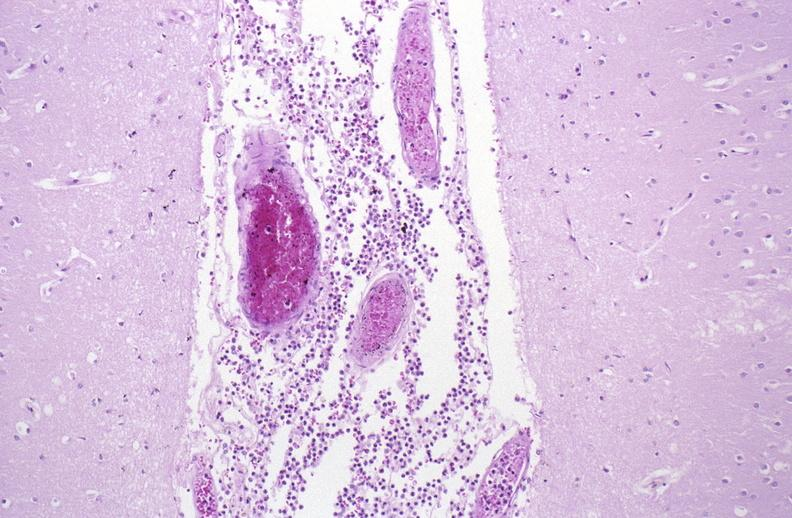s nervous present?
Answer the question using a single word or phrase. Yes 